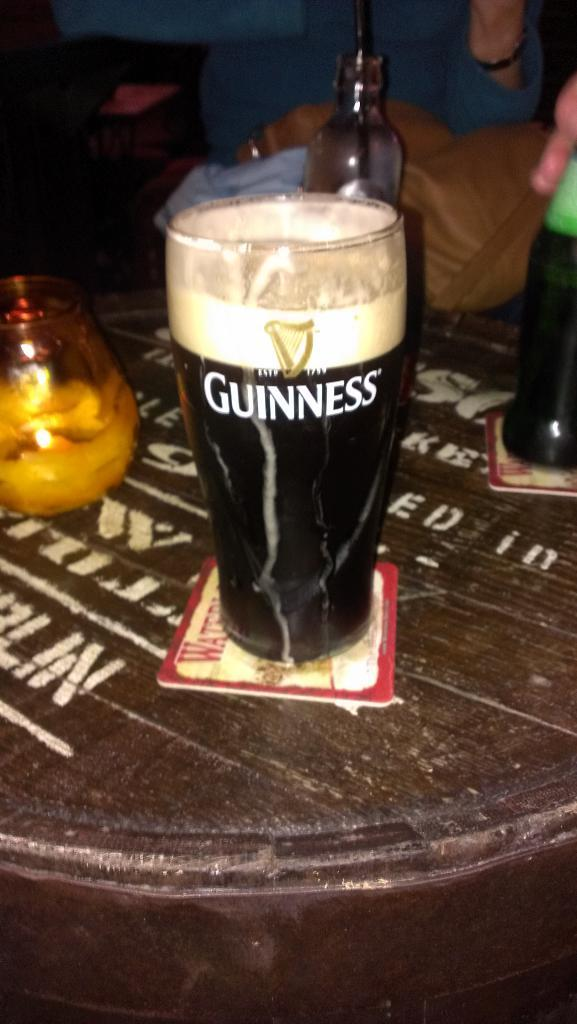<image>
Describe the image concisely. An almost full glass of Guinness is on a coaster. 